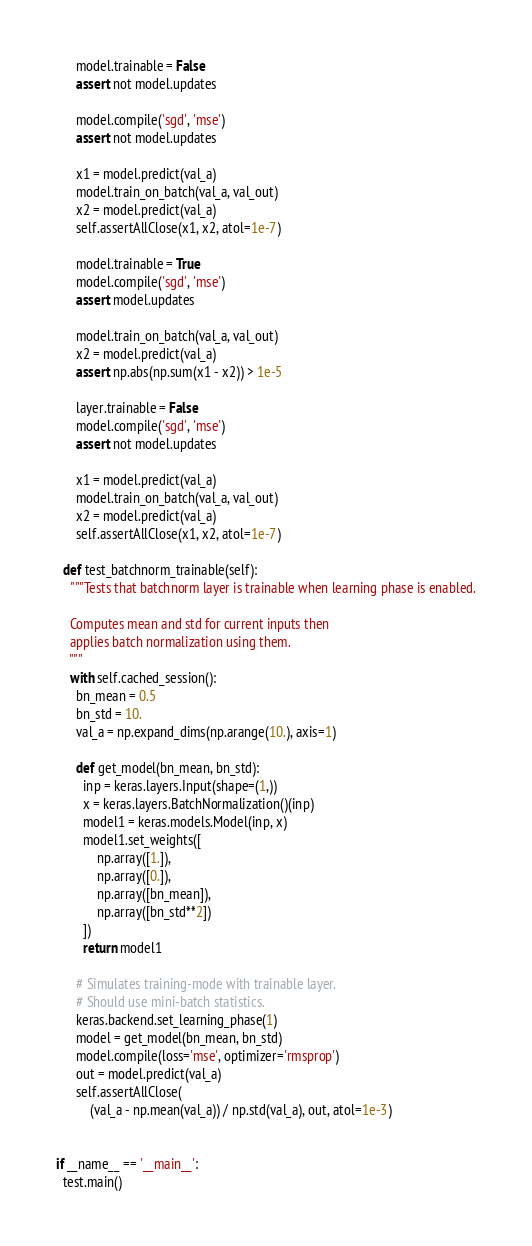<code> <loc_0><loc_0><loc_500><loc_500><_Python_>
      model.trainable = False
      assert not model.updates

      model.compile('sgd', 'mse')
      assert not model.updates

      x1 = model.predict(val_a)
      model.train_on_batch(val_a, val_out)
      x2 = model.predict(val_a)
      self.assertAllClose(x1, x2, atol=1e-7)

      model.trainable = True
      model.compile('sgd', 'mse')
      assert model.updates

      model.train_on_batch(val_a, val_out)
      x2 = model.predict(val_a)
      assert np.abs(np.sum(x1 - x2)) > 1e-5

      layer.trainable = False
      model.compile('sgd', 'mse')
      assert not model.updates

      x1 = model.predict(val_a)
      model.train_on_batch(val_a, val_out)
      x2 = model.predict(val_a)
      self.assertAllClose(x1, x2, atol=1e-7)

  def test_batchnorm_trainable(self):
    """Tests that batchnorm layer is trainable when learning phase is enabled.

    Computes mean and std for current inputs then
    applies batch normalization using them.
    """
    with self.cached_session():
      bn_mean = 0.5
      bn_std = 10.
      val_a = np.expand_dims(np.arange(10.), axis=1)

      def get_model(bn_mean, bn_std):
        inp = keras.layers.Input(shape=(1,))
        x = keras.layers.BatchNormalization()(inp)
        model1 = keras.models.Model(inp, x)
        model1.set_weights([
            np.array([1.]),
            np.array([0.]),
            np.array([bn_mean]),
            np.array([bn_std**2])
        ])
        return model1

      # Simulates training-mode with trainable layer.
      # Should use mini-batch statistics.
      keras.backend.set_learning_phase(1)
      model = get_model(bn_mean, bn_std)
      model.compile(loss='mse', optimizer='rmsprop')
      out = model.predict(val_a)
      self.assertAllClose(
          (val_a - np.mean(val_a)) / np.std(val_a), out, atol=1e-3)


if __name__ == '__main__':
  test.main()
</code> 